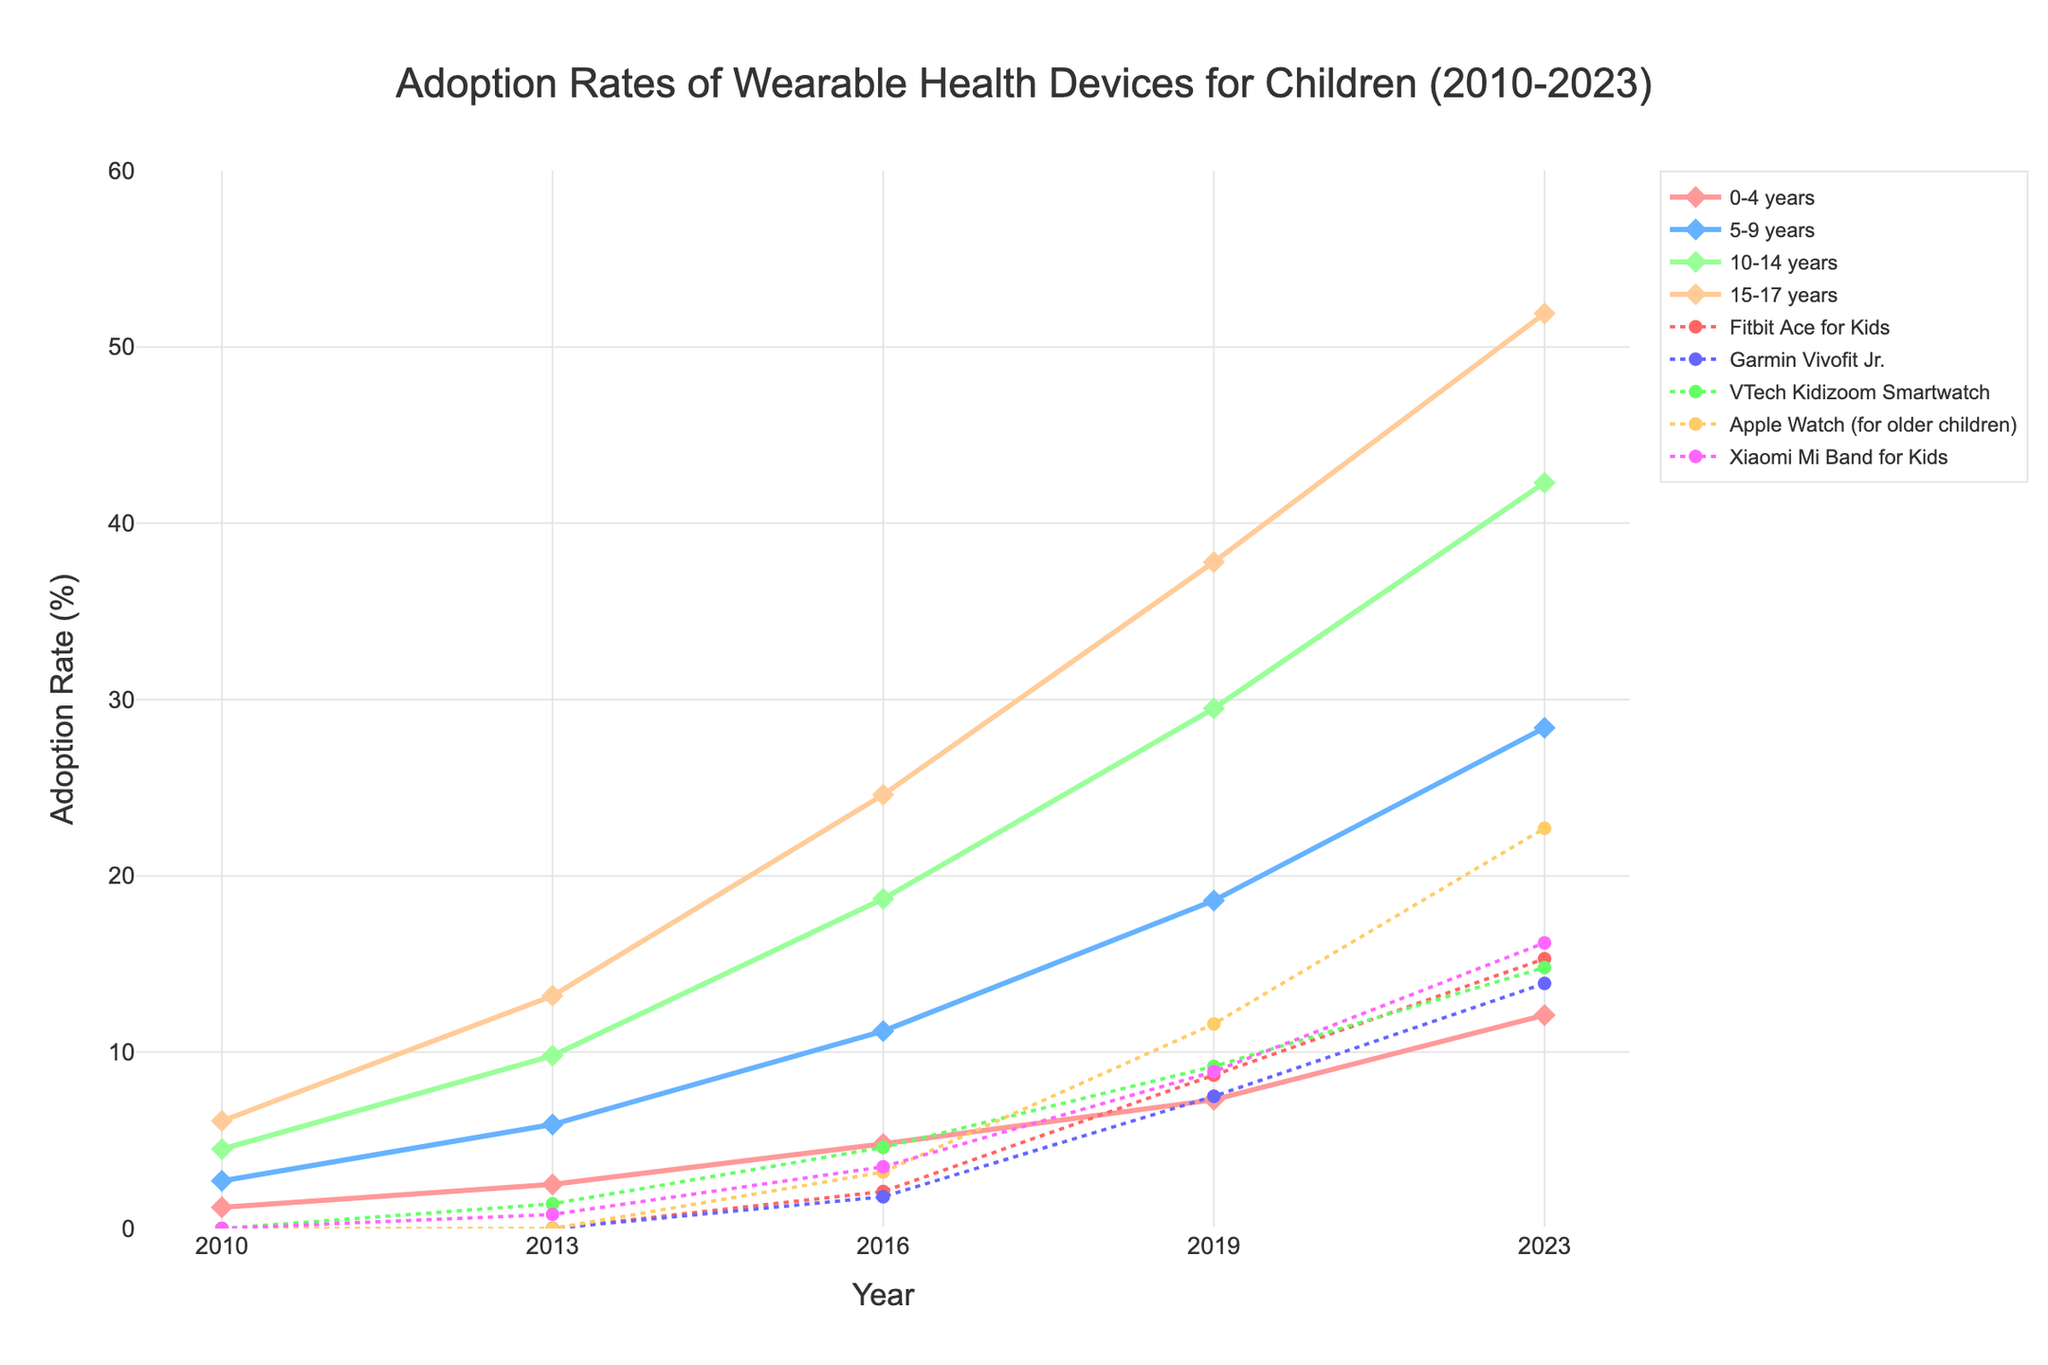What is the adoption rate for children aged 10-14 years in 2010? The 2010 adoption rate for children aged 10-14 years is found on the leftmost side of the line for the 10-14 years group. It is represented at 4.5%.
Answer: 4.5% Which age group had the highest adoption rate in 2023? To determine the highest adoption rate in 2023, we compare the values for each group in the year 2023. The 15-17 years group had the highest rate at 51.9%.
Answer: 15-17 years What is the difference in adoption rates between children aged 5-9 years and 15-17 years in 2016? Compare the adoption rates for both age groups in 2016. The rates are 11.2% for 5-9 years and 24.6% for 15-17 years. The difference is 24.6% - 11.2% = 13.4%.
Answer: 13.4% Which device had the lowest adoption rate in 2023? Compare the adoption rates for all devices in 2023. Garmin Vivofit Jr. had the lowest adoption rate of 13.9%.
Answer: Garmin Vivofit Jr By how much did the adoption rate increase for the group aged 0-4 years from 2010 to 2023? The adoption rate in 2010 was 1.2%, and in 2023 it was 12.1%. The increase is 12.1% - 1.2% = 10.9%.
Answer: 10.9% Between which consecutive years did children aged 5-9 years see the largest increase in adoption rate? Check the differences between consecutive years for the 5-9 years group. The largest increase happened between 2019 (18.6%) and 2023 (28.4%), with an increase of 28.4% - 18.6% = 9.8%.
Answer: 2019 to 2023 Which age group shows faster growth in adoption after 2016, the 10-14 years or 15-17 years group? Calculate the growth rates from 2016 to 2023: 10-14 years increase is 42.3% - 18.7% = 23.6%; 15-17 years increase is 51.9% - 24.6% = 27.3%. Thus, the 15-17 years group grows faster.
Answer: 15-17 years What is the average adoption rate of VTech Kidizoom Smartwatch from 2010 to 2023? Sum the adoption rates of VTech Kidizoom Smartwatch for all given years and divide by the number of years: (0% + 1.4% + 4.6% + 9.2% + 14.8%) / 5 = 6%.
Answer: 6% Is the adoption rate of Apple Watch (for older children) in 2023 greater than the adoption rate of the group aged 0-4 years in 2023? Compare the rates, which are 22.7% for Apple Watch and 12.1% for the 0-4 years group. The rate for Apple Watch is higher.
Answer: Yes Which device had the highest adoption rate in 2019 and what was it? Compare the 2019 adoption rates for all devices. Apple Watch had the highest adoption rate of 11.6%.
Answer: Apple Watch, 11.6% 